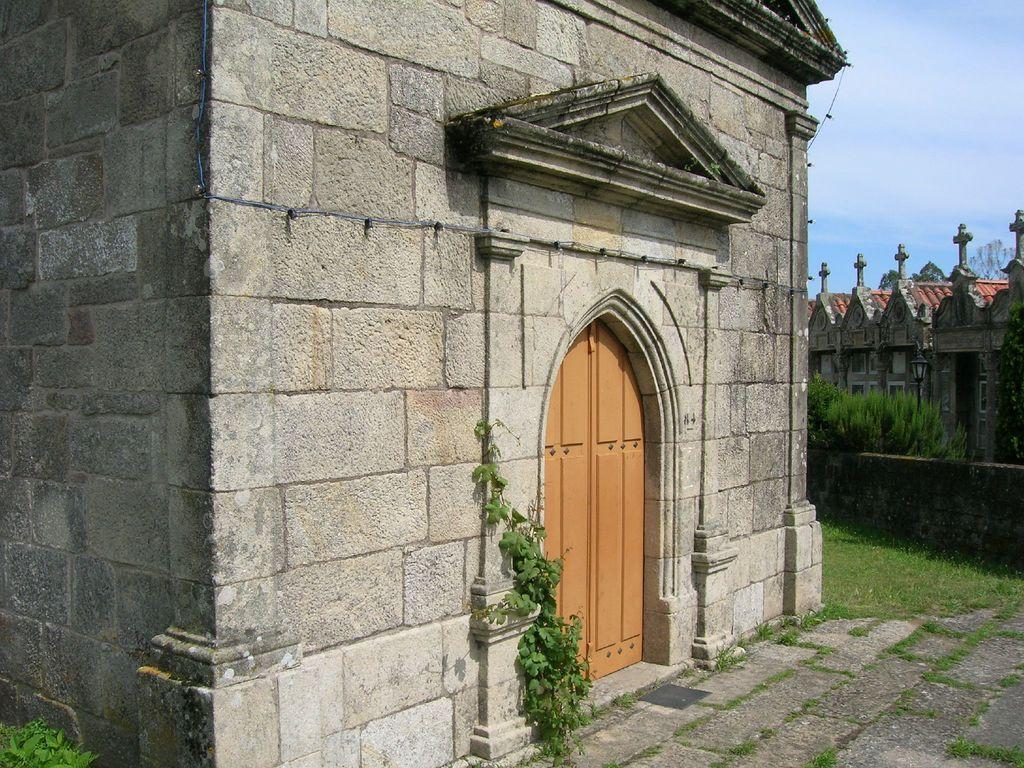Could you give a brief overview of what you see in this image? In this image there is a building. This is the door. This is looking like boundary. Here there are few plants. These are trees. 